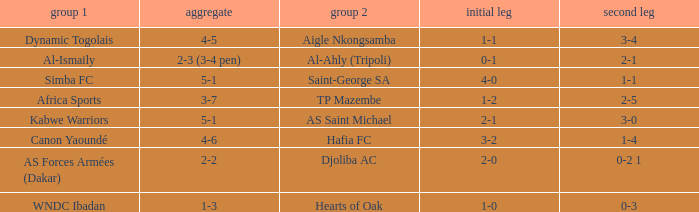What team played against Al-Ismaily (team 1)? Al-Ahly (Tripoli). 